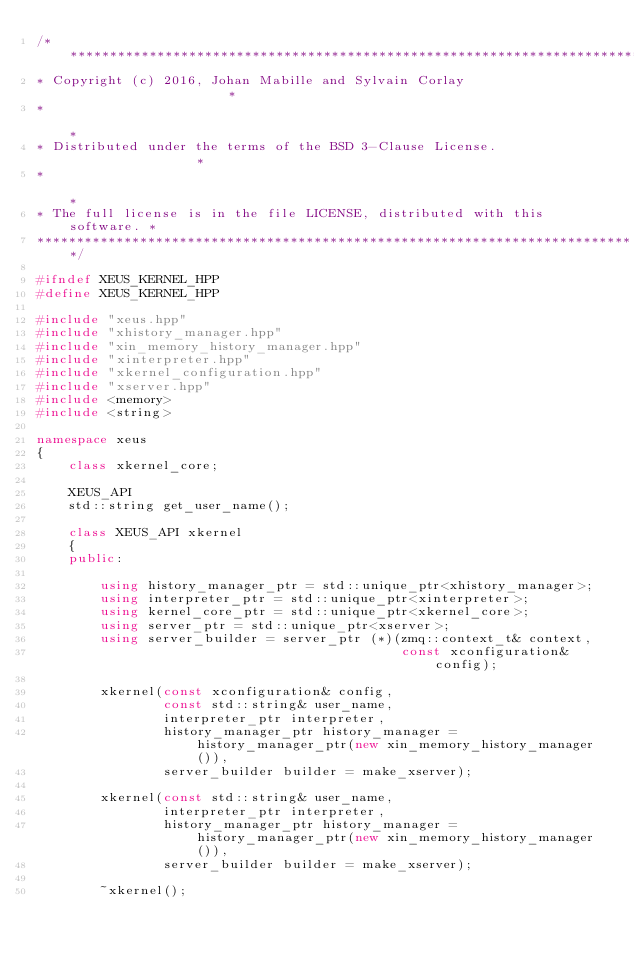<code> <loc_0><loc_0><loc_500><loc_500><_C++_>/***************************************************************************
* Copyright (c) 2016, Johan Mabille and Sylvain Corlay                     *
*                                                                          *
* Distributed under the terms of the BSD 3-Clause License.                 *
*                                                                          *
* The full license is in the file LICENSE, distributed with this software. *
****************************************************************************/

#ifndef XEUS_KERNEL_HPP
#define XEUS_KERNEL_HPP

#include "xeus.hpp"
#include "xhistory_manager.hpp"
#include "xin_memory_history_manager.hpp"
#include "xinterpreter.hpp"
#include "xkernel_configuration.hpp"
#include "xserver.hpp"
#include <memory>
#include <string>

namespace xeus
{
    class xkernel_core;

    XEUS_API
    std::string get_user_name();

    class XEUS_API xkernel
    {
    public:

        using history_manager_ptr = std::unique_ptr<xhistory_manager>;
        using interpreter_ptr = std::unique_ptr<xinterpreter>;
        using kernel_core_ptr = std::unique_ptr<xkernel_core>;
        using server_ptr = std::unique_ptr<xserver>;
        using server_builder = server_ptr (*)(zmq::context_t& context,
                                              const xconfiguration& config);

        xkernel(const xconfiguration& config,
                const std::string& user_name,
                interpreter_ptr interpreter,
                history_manager_ptr history_manager = history_manager_ptr(new xin_memory_history_manager()),
                server_builder builder = make_xserver);

        xkernel(const std::string& user_name,
                interpreter_ptr interpreter,
                history_manager_ptr history_manager = history_manager_ptr(new xin_memory_history_manager()),
                server_builder builder = make_xserver);

        ~xkernel();
</code> 